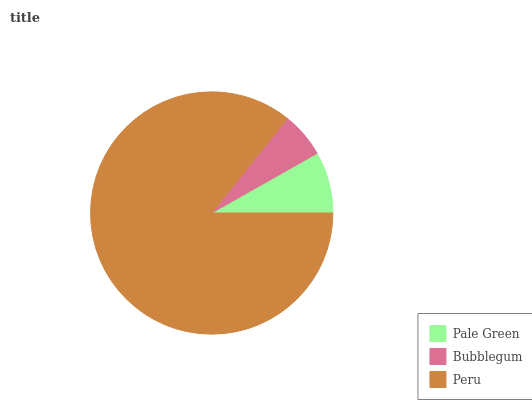Is Bubblegum the minimum?
Answer yes or no. Yes. Is Peru the maximum?
Answer yes or no. Yes. Is Peru the minimum?
Answer yes or no. No. Is Bubblegum the maximum?
Answer yes or no. No. Is Peru greater than Bubblegum?
Answer yes or no. Yes. Is Bubblegum less than Peru?
Answer yes or no. Yes. Is Bubblegum greater than Peru?
Answer yes or no. No. Is Peru less than Bubblegum?
Answer yes or no. No. Is Pale Green the high median?
Answer yes or no. Yes. Is Pale Green the low median?
Answer yes or no. Yes. Is Peru the high median?
Answer yes or no. No. Is Bubblegum the low median?
Answer yes or no. No. 